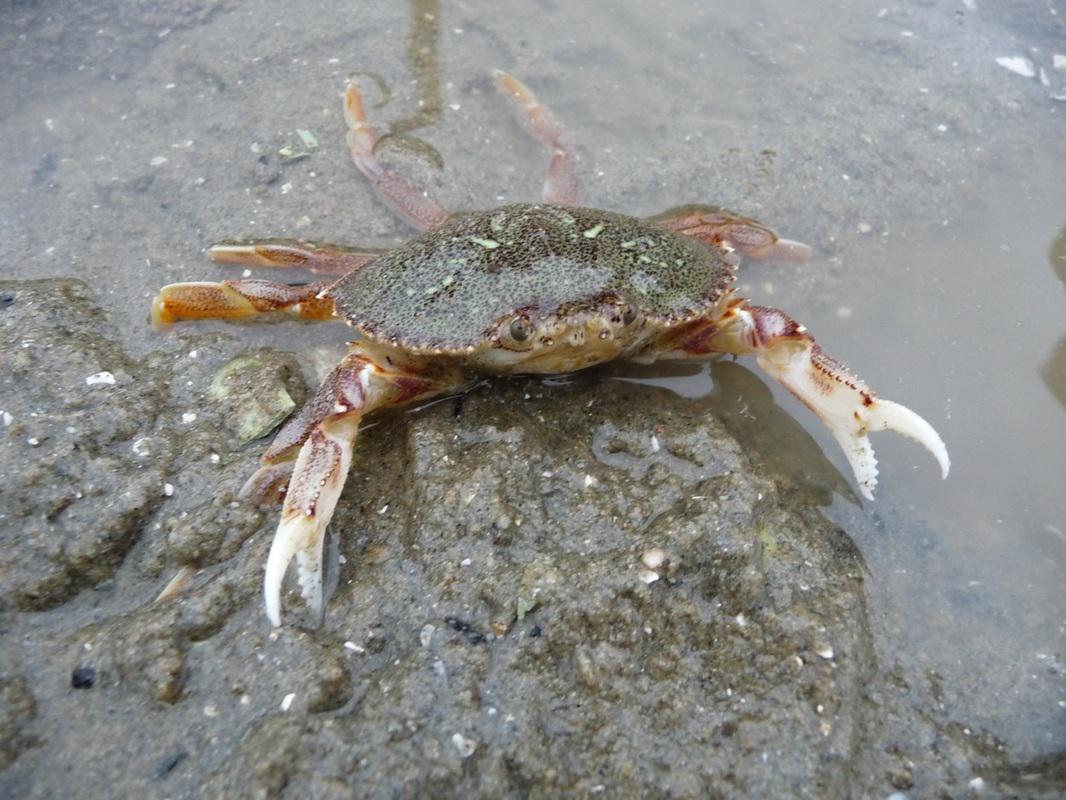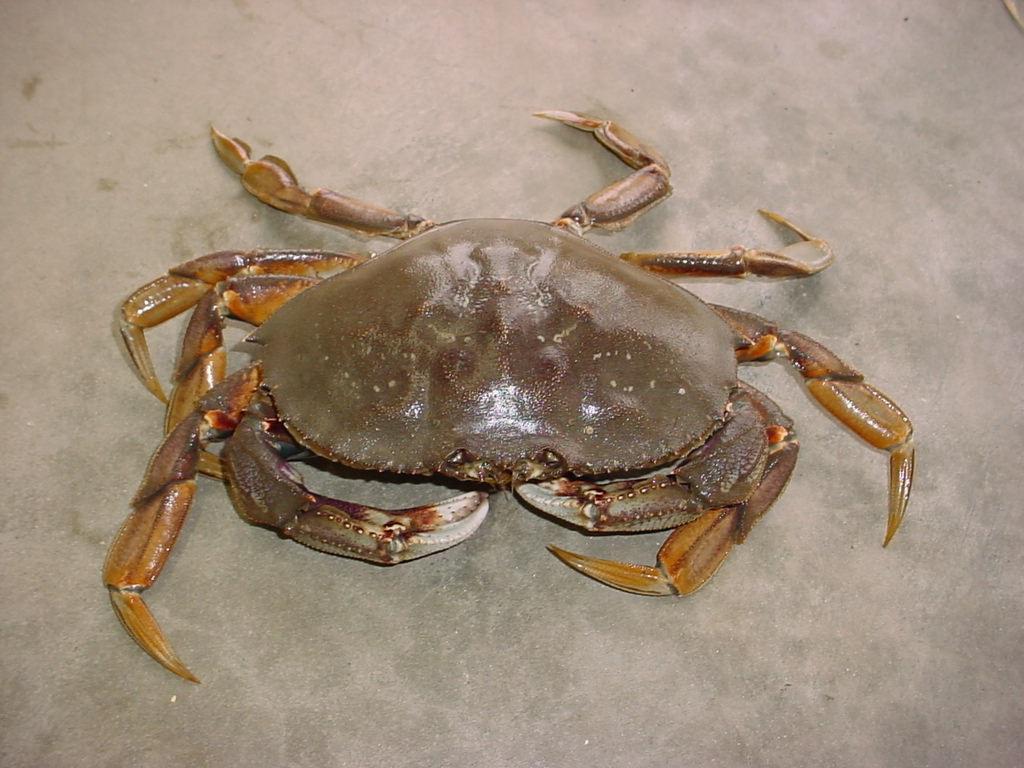The first image is the image on the left, the second image is the image on the right. Considering the images on both sides, is "The left and right image contains the same number of crabs in the sand." valid? Answer yes or no. Yes. The first image is the image on the left, the second image is the image on the right. Given the left and right images, does the statement "One of the crabs is a shade of purple, the other is a shade of brown." hold true? Answer yes or no. No. 